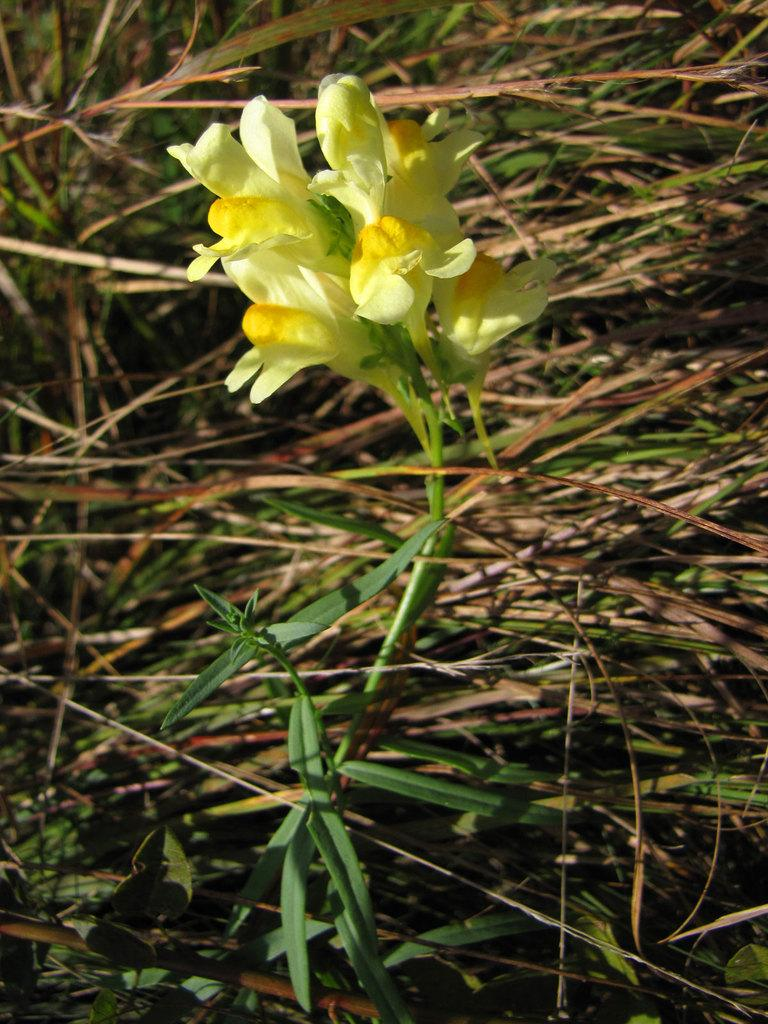What is the main subject in the center of the image? There is a flower in the center of the image. What type of vegetation is present at the bottom of the image? There is grass at the bottom of the image. What type of drawer can be seen in the image? There is no drawer present in the image; it features a flower and grass. Can you hear someone coughing in the image? There is no sound or indication of coughing in the image, as it is a still image. 